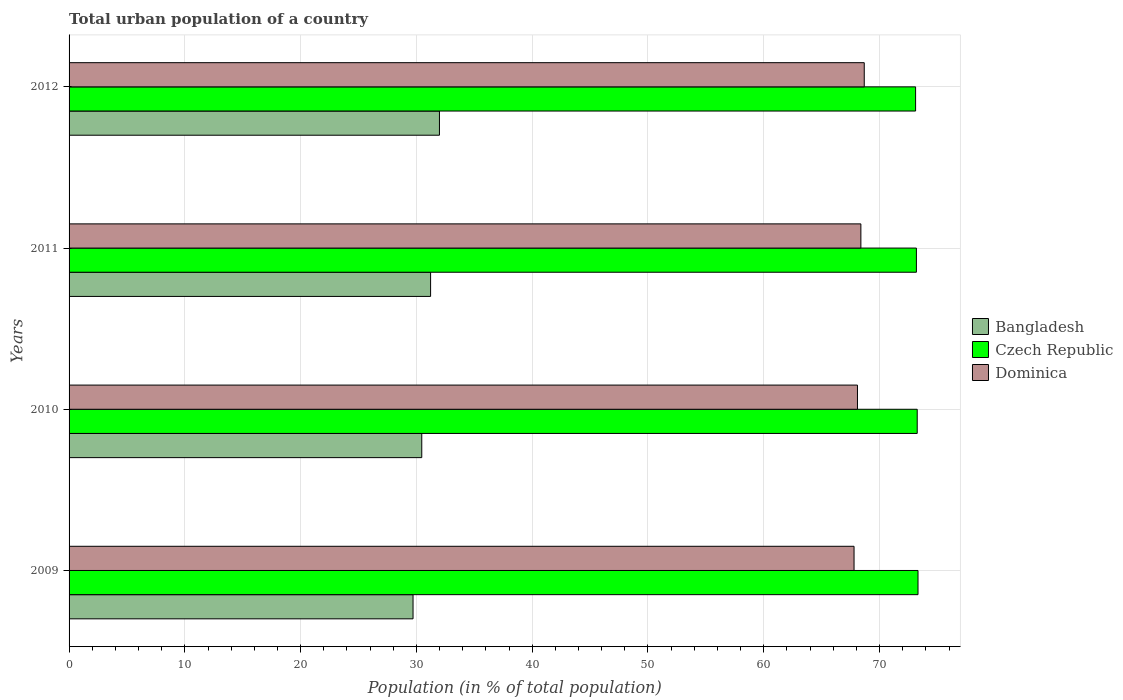How many bars are there on the 3rd tick from the top?
Your answer should be compact. 3. What is the label of the 4th group of bars from the top?
Provide a succinct answer. 2009. What is the urban population in Bangladesh in 2011?
Your answer should be very brief. 31.23. Across all years, what is the maximum urban population in Czech Republic?
Your answer should be compact. 73.32. Across all years, what is the minimum urban population in Dominica?
Give a very brief answer. 67.8. What is the total urban population in Czech Republic in the graph?
Make the answer very short. 292.88. What is the difference between the urban population in Czech Republic in 2009 and that in 2011?
Provide a succinct answer. 0.14. What is the difference between the urban population in Bangladesh in 2009 and the urban population in Czech Republic in 2012?
Your answer should be compact. -43.41. What is the average urban population in Bangladesh per year?
Your response must be concise. 30.85. In the year 2009, what is the difference between the urban population in Bangladesh and urban population in Czech Republic?
Your response must be concise. -43.61. In how many years, is the urban population in Czech Republic greater than 40 %?
Provide a succinct answer. 4. What is the ratio of the urban population in Bangladesh in 2009 to that in 2011?
Provide a short and direct response. 0.95. Is the urban population in Dominica in 2009 less than that in 2012?
Provide a short and direct response. Yes. What is the difference between the highest and the second highest urban population in Czech Republic?
Your response must be concise. 0.07. What is the difference between the highest and the lowest urban population in Dominica?
Provide a succinct answer. 0.88. What does the 1st bar from the top in 2009 represents?
Make the answer very short. Dominica. What does the 2nd bar from the bottom in 2012 represents?
Make the answer very short. Czech Republic. How many bars are there?
Keep it short and to the point. 12. Are all the bars in the graph horizontal?
Your response must be concise. Yes. How many years are there in the graph?
Offer a very short reply. 4. What is the difference between two consecutive major ticks on the X-axis?
Make the answer very short. 10. Does the graph contain any zero values?
Offer a very short reply. No. Does the graph contain grids?
Your answer should be very brief. Yes. How many legend labels are there?
Provide a short and direct response. 3. What is the title of the graph?
Your response must be concise. Total urban population of a country. Does "Botswana" appear as one of the legend labels in the graph?
Provide a succinct answer. No. What is the label or title of the X-axis?
Your answer should be very brief. Population (in % of total population). What is the label or title of the Y-axis?
Keep it short and to the point. Years. What is the Population (in % of total population) in Bangladesh in 2009?
Give a very brief answer. 29.71. What is the Population (in % of total population) of Czech Republic in 2009?
Offer a very short reply. 73.32. What is the Population (in % of total population) in Dominica in 2009?
Offer a terse response. 67.8. What is the Population (in % of total population) in Bangladesh in 2010?
Your answer should be very brief. 30.46. What is the Population (in % of total population) of Czech Republic in 2010?
Provide a succinct answer. 73.25. What is the Population (in % of total population) in Dominica in 2010?
Make the answer very short. 68.09. What is the Population (in % of total population) in Bangladesh in 2011?
Provide a short and direct response. 31.23. What is the Population (in % of total population) of Czech Republic in 2011?
Your answer should be compact. 73.19. What is the Population (in % of total population) in Dominica in 2011?
Your response must be concise. 68.39. What is the Population (in % of total population) of Bangladesh in 2012?
Provide a short and direct response. 31.99. What is the Population (in % of total population) in Czech Republic in 2012?
Keep it short and to the point. 73.11. What is the Population (in % of total population) in Dominica in 2012?
Provide a short and direct response. 68.68. Across all years, what is the maximum Population (in % of total population) in Bangladesh?
Provide a short and direct response. 31.99. Across all years, what is the maximum Population (in % of total population) in Czech Republic?
Keep it short and to the point. 73.32. Across all years, what is the maximum Population (in % of total population) of Dominica?
Offer a terse response. 68.68. Across all years, what is the minimum Population (in % of total population) in Bangladesh?
Your answer should be very brief. 29.71. Across all years, what is the minimum Population (in % of total population) in Czech Republic?
Ensure brevity in your answer.  73.11. Across all years, what is the minimum Population (in % of total population) of Dominica?
Keep it short and to the point. 67.8. What is the total Population (in % of total population) in Bangladesh in the graph?
Provide a short and direct response. 123.39. What is the total Population (in % of total population) of Czech Republic in the graph?
Make the answer very short. 292.88. What is the total Population (in % of total population) of Dominica in the graph?
Your response must be concise. 272.96. What is the difference between the Population (in % of total population) of Bangladesh in 2009 and that in 2010?
Ensure brevity in your answer.  -0.75. What is the difference between the Population (in % of total population) in Czech Republic in 2009 and that in 2010?
Your answer should be very brief. 0.07. What is the difference between the Population (in % of total population) of Dominica in 2009 and that in 2010?
Your answer should be compact. -0.29. What is the difference between the Population (in % of total population) in Bangladesh in 2009 and that in 2011?
Make the answer very short. -1.52. What is the difference between the Population (in % of total population) in Czech Republic in 2009 and that in 2011?
Offer a very short reply. 0.14. What is the difference between the Population (in % of total population) of Dominica in 2009 and that in 2011?
Ensure brevity in your answer.  -0.59. What is the difference between the Population (in % of total population) of Bangladesh in 2009 and that in 2012?
Your response must be concise. -2.28. What is the difference between the Population (in % of total population) of Czech Republic in 2009 and that in 2012?
Ensure brevity in your answer.  0.21. What is the difference between the Population (in % of total population) of Dominica in 2009 and that in 2012?
Give a very brief answer. -0.88. What is the difference between the Population (in % of total population) in Bangladesh in 2010 and that in 2011?
Offer a terse response. -0.76. What is the difference between the Population (in % of total population) in Czech Republic in 2010 and that in 2011?
Give a very brief answer. 0.07. What is the difference between the Population (in % of total population) of Dominica in 2010 and that in 2011?
Give a very brief answer. -0.29. What is the difference between the Population (in % of total population) in Bangladesh in 2010 and that in 2012?
Your response must be concise. -1.53. What is the difference between the Population (in % of total population) of Czech Republic in 2010 and that in 2012?
Make the answer very short. 0.14. What is the difference between the Population (in % of total population) of Dominica in 2010 and that in 2012?
Offer a terse response. -0.59. What is the difference between the Population (in % of total population) in Bangladesh in 2011 and that in 2012?
Ensure brevity in your answer.  -0.77. What is the difference between the Population (in % of total population) of Czech Republic in 2011 and that in 2012?
Your response must be concise. 0.07. What is the difference between the Population (in % of total population) of Dominica in 2011 and that in 2012?
Your answer should be compact. -0.29. What is the difference between the Population (in % of total population) of Bangladesh in 2009 and the Population (in % of total population) of Czech Republic in 2010?
Make the answer very short. -43.55. What is the difference between the Population (in % of total population) in Bangladesh in 2009 and the Population (in % of total population) in Dominica in 2010?
Give a very brief answer. -38.38. What is the difference between the Population (in % of total population) in Czech Republic in 2009 and the Population (in % of total population) in Dominica in 2010?
Your response must be concise. 5.23. What is the difference between the Population (in % of total population) in Bangladesh in 2009 and the Population (in % of total population) in Czech Republic in 2011?
Your answer should be very brief. -43.48. What is the difference between the Population (in % of total population) of Bangladesh in 2009 and the Population (in % of total population) of Dominica in 2011?
Your answer should be very brief. -38.68. What is the difference between the Population (in % of total population) of Czech Republic in 2009 and the Population (in % of total population) of Dominica in 2011?
Provide a succinct answer. 4.93. What is the difference between the Population (in % of total population) of Bangladesh in 2009 and the Population (in % of total population) of Czech Republic in 2012?
Your answer should be compact. -43.41. What is the difference between the Population (in % of total population) of Bangladesh in 2009 and the Population (in % of total population) of Dominica in 2012?
Your answer should be very brief. -38.97. What is the difference between the Population (in % of total population) in Czech Republic in 2009 and the Population (in % of total population) in Dominica in 2012?
Your answer should be compact. 4.64. What is the difference between the Population (in % of total population) of Bangladesh in 2010 and the Population (in % of total population) of Czech Republic in 2011?
Ensure brevity in your answer.  -42.72. What is the difference between the Population (in % of total population) in Bangladesh in 2010 and the Population (in % of total population) in Dominica in 2011?
Your response must be concise. -37.93. What is the difference between the Population (in % of total population) in Czech Republic in 2010 and the Population (in % of total population) in Dominica in 2011?
Provide a short and direct response. 4.87. What is the difference between the Population (in % of total population) of Bangladesh in 2010 and the Population (in % of total population) of Czech Republic in 2012?
Ensure brevity in your answer.  -42.65. What is the difference between the Population (in % of total population) in Bangladesh in 2010 and the Population (in % of total population) in Dominica in 2012?
Provide a succinct answer. -38.22. What is the difference between the Population (in % of total population) in Czech Republic in 2010 and the Population (in % of total population) in Dominica in 2012?
Your answer should be compact. 4.57. What is the difference between the Population (in % of total population) of Bangladesh in 2011 and the Population (in % of total population) of Czech Republic in 2012?
Provide a short and direct response. -41.89. What is the difference between the Population (in % of total population) of Bangladesh in 2011 and the Population (in % of total population) of Dominica in 2012?
Give a very brief answer. -37.46. What is the difference between the Population (in % of total population) in Czech Republic in 2011 and the Population (in % of total population) in Dominica in 2012?
Your response must be concise. 4.5. What is the average Population (in % of total population) in Bangladesh per year?
Keep it short and to the point. 30.85. What is the average Population (in % of total population) in Czech Republic per year?
Provide a succinct answer. 73.22. What is the average Population (in % of total population) of Dominica per year?
Your response must be concise. 68.24. In the year 2009, what is the difference between the Population (in % of total population) in Bangladesh and Population (in % of total population) in Czech Republic?
Make the answer very short. -43.62. In the year 2009, what is the difference between the Population (in % of total population) of Bangladesh and Population (in % of total population) of Dominica?
Give a very brief answer. -38.09. In the year 2009, what is the difference between the Population (in % of total population) in Czech Republic and Population (in % of total population) in Dominica?
Provide a succinct answer. 5.53. In the year 2010, what is the difference between the Population (in % of total population) in Bangladesh and Population (in % of total population) in Czech Republic?
Your answer should be compact. -42.79. In the year 2010, what is the difference between the Population (in % of total population) of Bangladesh and Population (in % of total population) of Dominica?
Your answer should be very brief. -37.63. In the year 2010, what is the difference between the Population (in % of total population) in Czech Republic and Population (in % of total population) in Dominica?
Make the answer very short. 5.16. In the year 2011, what is the difference between the Population (in % of total population) of Bangladesh and Population (in % of total population) of Czech Republic?
Give a very brief answer. -41.96. In the year 2011, what is the difference between the Population (in % of total population) in Bangladesh and Population (in % of total population) in Dominica?
Your answer should be very brief. -37.16. In the year 2011, what is the difference between the Population (in % of total population) in Czech Republic and Population (in % of total population) in Dominica?
Your answer should be compact. 4.8. In the year 2012, what is the difference between the Population (in % of total population) of Bangladesh and Population (in % of total population) of Czech Republic?
Keep it short and to the point. -41.12. In the year 2012, what is the difference between the Population (in % of total population) of Bangladesh and Population (in % of total population) of Dominica?
Your answer should be compact. -36.69. In the year 2012, what is the difference between the Population (in % of total population) of Czech Republic and Population (in % of total population) of Dominica?
Offer a terse response. 4.43. What is the ratio of the Population (in % of total population) in Bangladesh in 2009 to that in 2010?
Offer a very short reply. 0.98. What is the ratio of the Population (in % of total population) of Czech Republic in 2009 to that in 2010?
Your answer should be very brief. 1. What is the ratio of the Population (in % of total population) of Bangladesh in 2009 to that in 2011?
Ensure brevity in your answer.  0.95. What is the ratio of the Population (in % of total population) in Dominica in 2009 to that in 2011?
Offer a very short reply. 0.99. What is the ratio of the Population (in % of total population) in Bangladesh in 2009 to that in 2012?
Ensure brevity in your answer.  0.93. What is the ratio of the Population (in % of total population) of Dominica in 2009 to that in 2012?
Your answer should be very brief. 0.99. What is the ratio of the Population (in % of total population) of Bangladesh in 2010 to that in 2011?
Your answer should be compact. 0.98. What is the ratio of the Population (in % of total population) in Bangladesh in 2010 to that in 2012?
Your answer should be very brief. 0.95. What is the ratio of the Population (in % of total population) of Czech Republic in 2010 to that in 2012?
Provide a short and direct response. 1. What is the ratio of the Population (in % of total population) of Bangladesh in 2011 to that in 2012?
Keep it short and to the point. 0.98. What is the ratio of the Population (in % of total population) of Dominica in 2011 to that in 2012?
Give a very brief answer. 1. What is the difference between the highest and the second highest Population (in % of total population) of Bangladesh?
Ensure brevity in your answer.  0.77. What is the difference between the highest and the second highest Population (in % of total population) of Czech Republic?
Your answer should be very brief. 0.07. What is the difference between the highest and the second highest Population (in % of total population) of Dominica?
Your response must be concise. 0.29. What is the difference between the highest and the lowest Population (in % of total population) of Bangladesh?
Offer a very short reply. 2.28. What is the difference between the highest and the lowest Population (in % of total population) of Czech Republic?
Offer a terse response. 0.21. What is the difference between the highest and the lowest Population (in % of total population) in Dominica?
Offer a terse response. 0.88. 